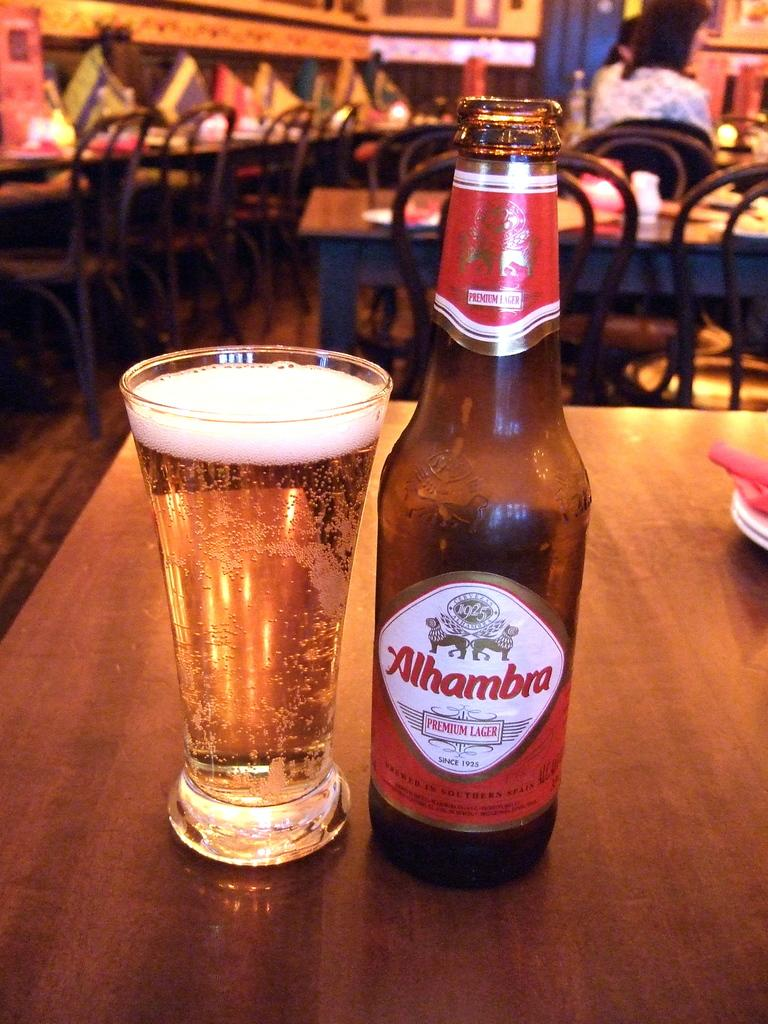<image>
Relay a brief, clear account of the picture shown. A restaurant table holds a Alhambra bottle with a glass full next to it. 